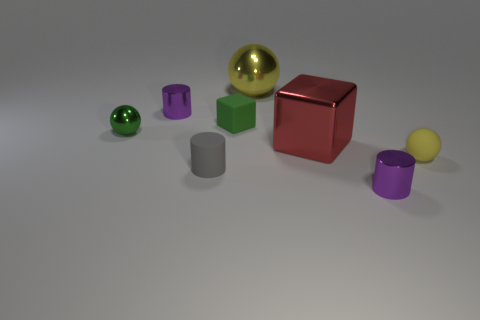Add 1 big metallic things. How many objects exist? 9 Subtract all spheres. How many objects are left? 5 Add 1 green rubber objects. How many green rubber objects are left? 2 Add 6 gray matte things. How many gray matte things exist? 7 Subtract 0 brown balls. How many objects are left? 8 Subtract all big purple objects. Subtract all tiny green things. How many objects are left? 6 